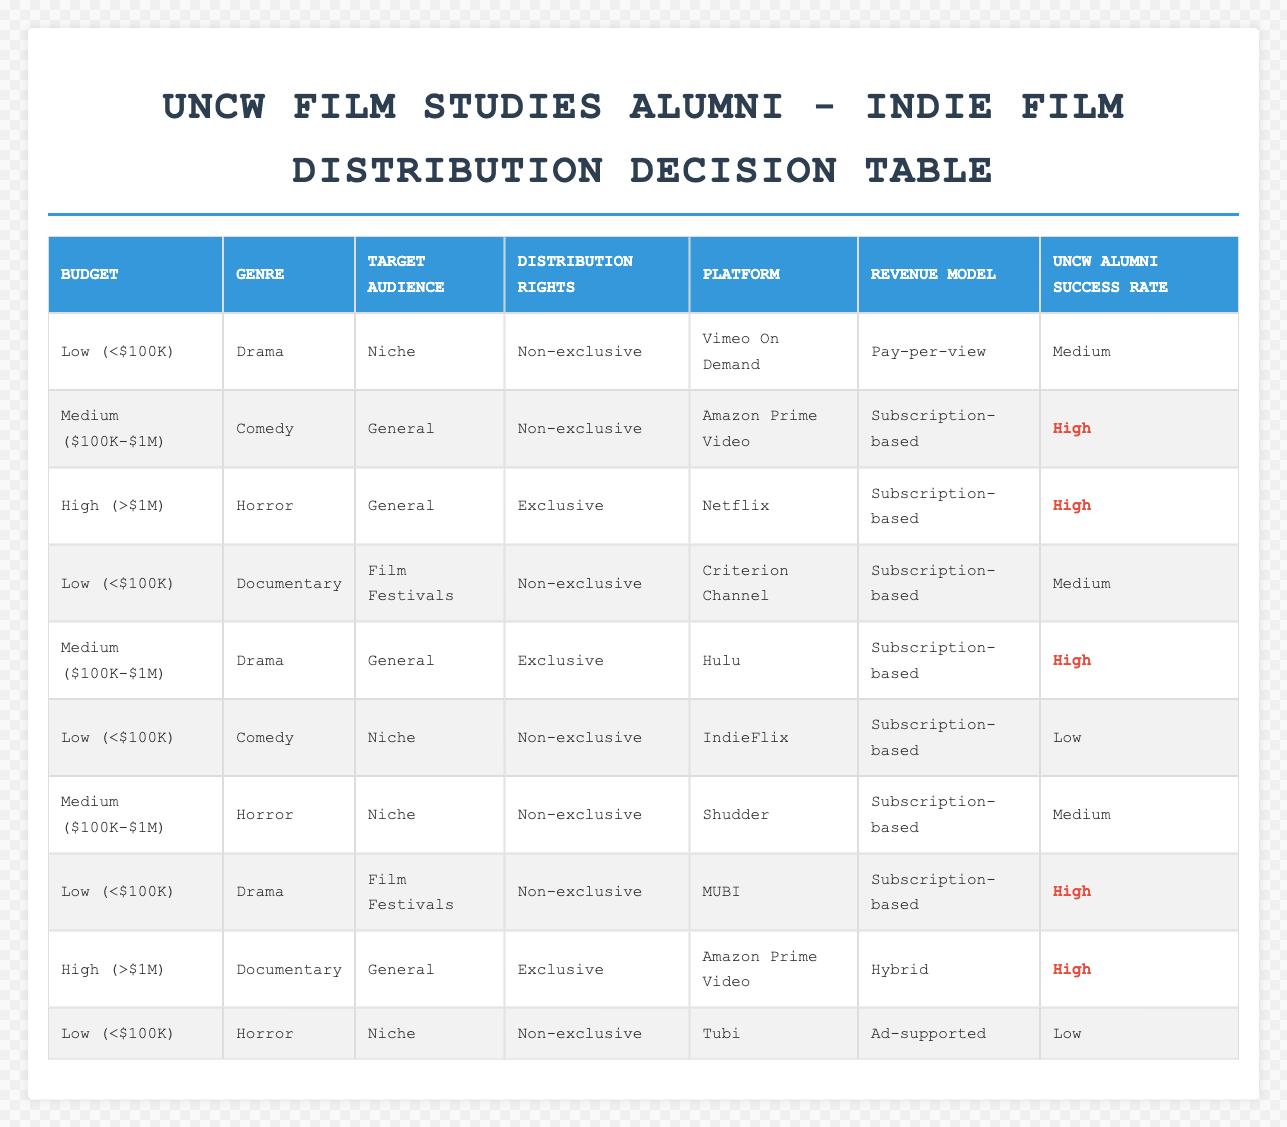What distribution platform is recommended for a low-budget drama targeting a niche audience with non-exclusive rights? According to the table, for a low budget drama aimed at a niche audience and with non-exclusive rights, the recommended platform is Vimeo On Demand. This is found in the first row of the table.
Answer: Vimeo On Demand Which genre leads to the highest success rate for medium-budget films with non-exclusive rights targeting a general audience? The table shows that medium-budget comedy films targeting a general audience and having non-exclusive rights are associated with a high success rate on Amazon Prime Video. Therefore, comedy is the genre for that combination.
Answer: Comedy Is there a low success rate for horror films with low budgets and niche target audiences on any distribution platform? Yes, the table indicates that low-budget horror films targeting a niche audience and having non-exclusive rights have a low success rate on Tubi, as shown in the last row.
Answer: Yes What is the average success rate of films on exclusive platforms in the medium-budget category across all genres? In the table, the medium-budget category with exclusive rights appears twice (drama and horror). Both have a high success rate. The average success rate is computed as (high + high) / 2, which equals high.
Answer: High For which budget category and genre combination is the Amazon Prime Video platform used with a hybrid revenue model? The table specifies that the Amazon Prime Video platform, when paired with a high budget and a documentary genre, has a hybrid revenue model. This combination is located in the second to last row of the table.
Answer: High budget documentary What is the least favorable revenue model for low-budget comedy films targeting a niche audience? The least favorable revenue model for low-budget comedy films aimed at a niche audience is pay-per-view, which applies to IndieFlix based on the table data in the sixth row.
Answer: Pay-per-view Does the table show any platform that has a medium success rate? Yes, there are two instances in the table where the success rate is medium: for low-budget drama on Vimeo On Demand and for medium-budget horror films on Shudder. Both platforms are listed with a medium success rate.
Answer: Yes Which genre has the highest number of associated distribution platforms for low-budget films? By examining the table, we see that drama appears three times (with different target audiences and rights) for low-budget films. Thus, drama has the most associated platforms, including Vimeo On Demand, MUBI, and Tubi.
Answer: Drama 